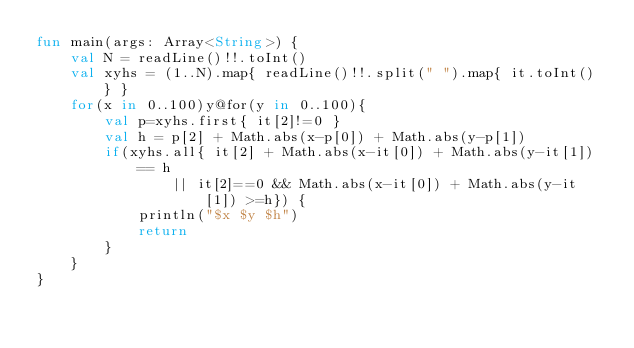<code> <loc_0><loc_0><loc_500><loc_500><_Kotlin_>fun main(args: Array<String>) {
    val N = readLine()!!.toInt()
    val xyhs = (1..N).map{ readLine()!!.split(" ").map{ it.toInt() } }
    for(x in 0..100)y@for(y in 0..100){
        val p=xyhs.first{ it[2]!=0 }
        val h = p[2] + Math.abs(x-p[0]) + Math.abs(y-p[1])
        if(xyhs.all{ it[2] + Math.abs(x-it[0]) + Math.abs(y-it[1]) == h
                || it[2]==0 && Math.abs(x-it[0]) + Math.abs(y-it[1]) >=h}) {
            println("$x $y $h")
            return
        }
    }
}</code> 